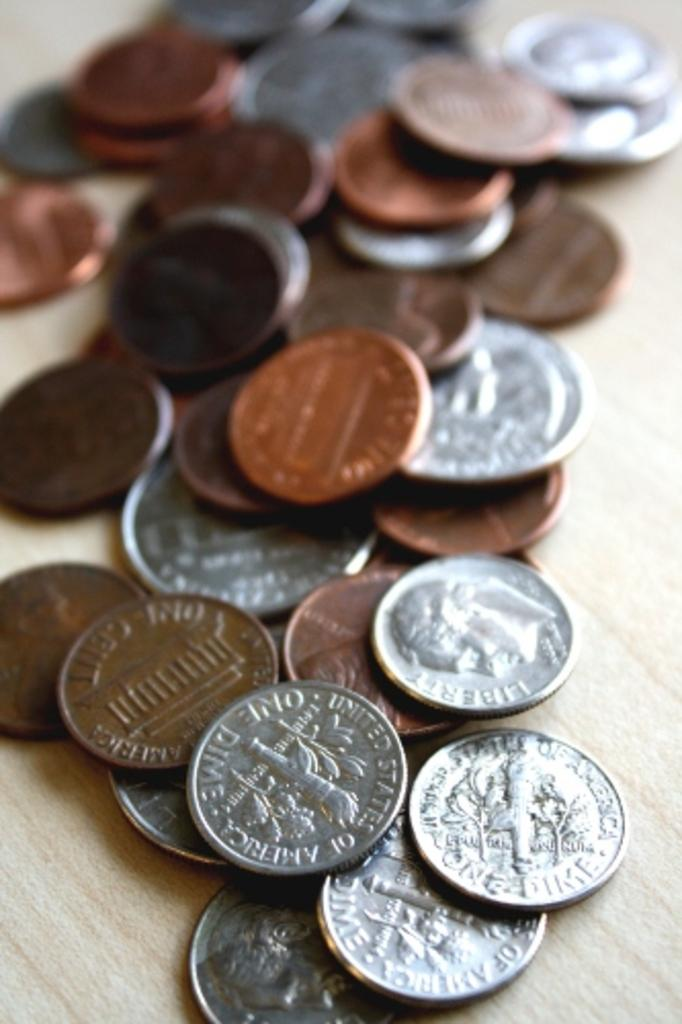<image>
Describe the image concisely. Coins are on the table, one of which reads "one dime." 